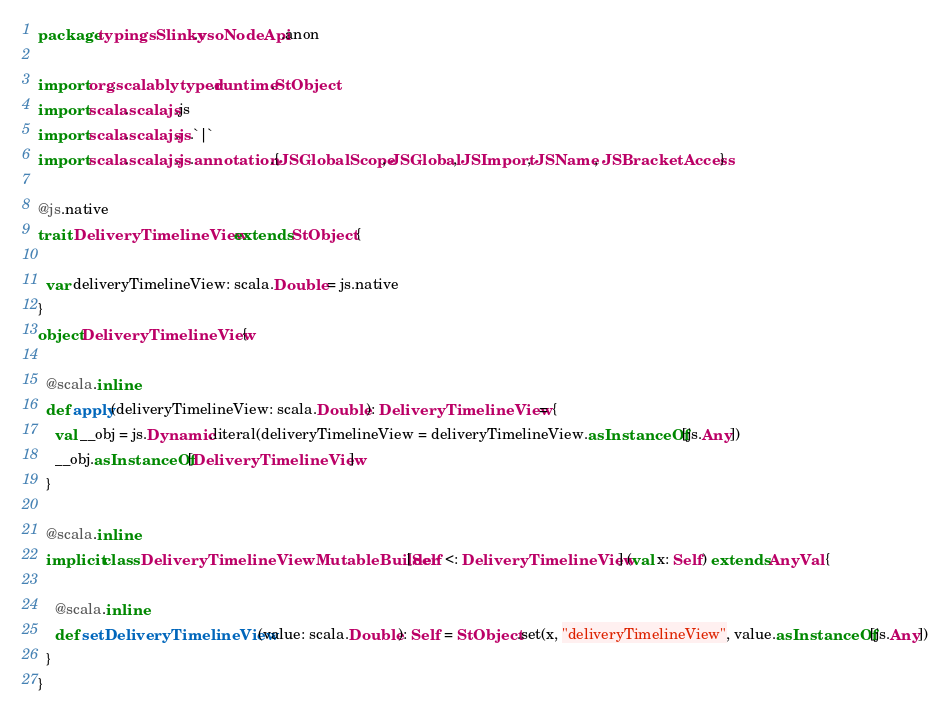<code> <loc_0><loc_0><loc_500><loc_500><_Scala_>package typingsSlinky.vsoNodeApi.anon

import org.scalablytyped.runtime.StObject
import scala.scalajs.js
import scala.scalajs.js.`|`
import scala.scalajs.js.annotation.{JSGlobalScope, JSGlobal, JSImport, JSName, JSBracketAccess}

@js.native
trait DeliveryTimelineView extends StObject {
  
  var deliveryTimelineView: scala.Double = js.native
}
object DeliveryTimelineView {
  
  @scala.inline
  def apply(deliveryTimelineView: scala.Double): DeliveryTimelineView = {
    val __obj = js.Dynamic.literal(deliveryTimelineView = deliveryTimelineView.asInstanceOf[js.Any])
    __obj.asInstanceOf[DeliveryTimelineView]
  }
  
  @scala.inline
  implicit class DeliveryTimelineViewMutableBuilder[Self <: DeliveryTimelineView] (val x: Self) extends AnyVal {
    
    @scala.inline
    def setDeliveryTimelineView(value: scala.Double): Self = StObject.set(x, "deliveryTimelineView", value.asInstanceOf[js.Any])
  }
}
</code> 